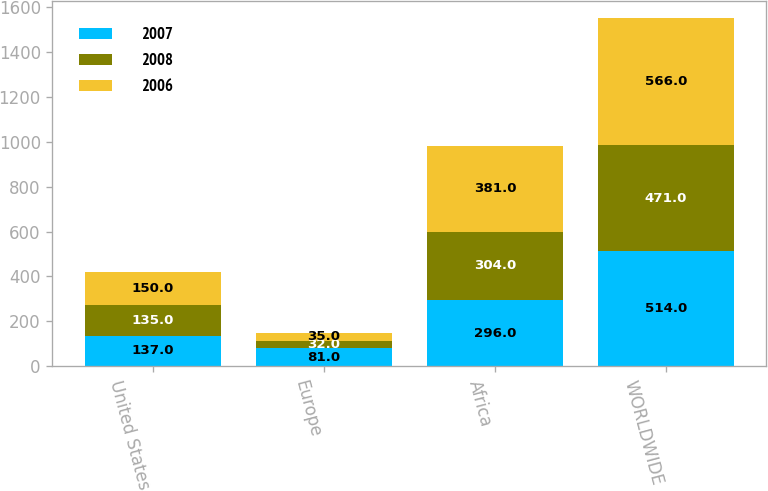Convert chart to OTSL. <chart><loc_0><loc_0><loc_500><loc_500><stacked_bar_chart><ecel><fcel>United States<fcel>Europe<fcel>Africa<fcel>WORLDWIDE<nl><fcel>2007<fcel>137<fcel>81<fcel>296<fcel>514<nl><fcel>2008<fcel>135<fcel>32<fcel>304<fcel>471<nl><fcel>2006<fcel>150<fcel>35<fcel>381<fcel>566<nl></chart> 